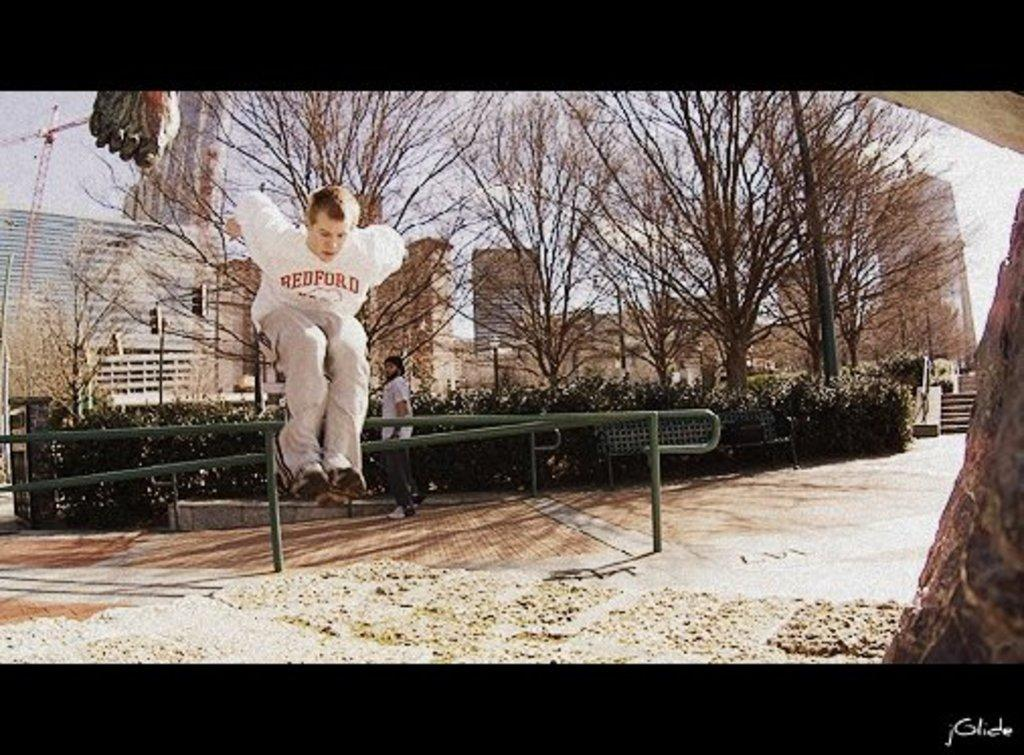Who is the main subject in the image? There is a man in the image. What is the man doing in the image? The man is jumping from a pole. What can be seen in the background of the image? There are trees and buildings visible in the image. What type of authority does the man have in the image? There is no indication of the man's authority in the image. Can you tell me how much credit the man has in the image? There is no mention of credit or financial matters in the image. 